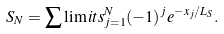Convert formula to latex. <formula><loc_0><loc_0><loc_500><loc_500>S _ { N } = \sum \lim i t s _ { j = 1 } ^ { N } ( - 1 ) ^ { j } { e } ^ { - x _ { j } / L _ { S } } .</formula> 